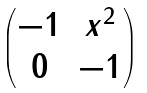Convert formula to latex. <formula><loc_0><loc_0><loc_500><loc_500>\begin{pmatrix} - 1 & x ^ { 2 } \\ 0 & - 1 \end{pmatrix}</formula> 